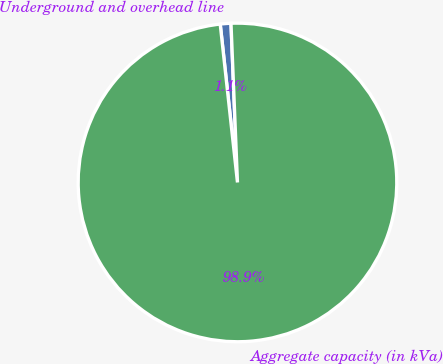Convert chart. <chart><loc_0><loc_0><loc_500><loc_500><pie_chart><fcel>Underground and overhead line<fcel>Aggregate capacity (in kVa)<nl><fcel>1.08%<fcel>98.92%<nl></chart> 